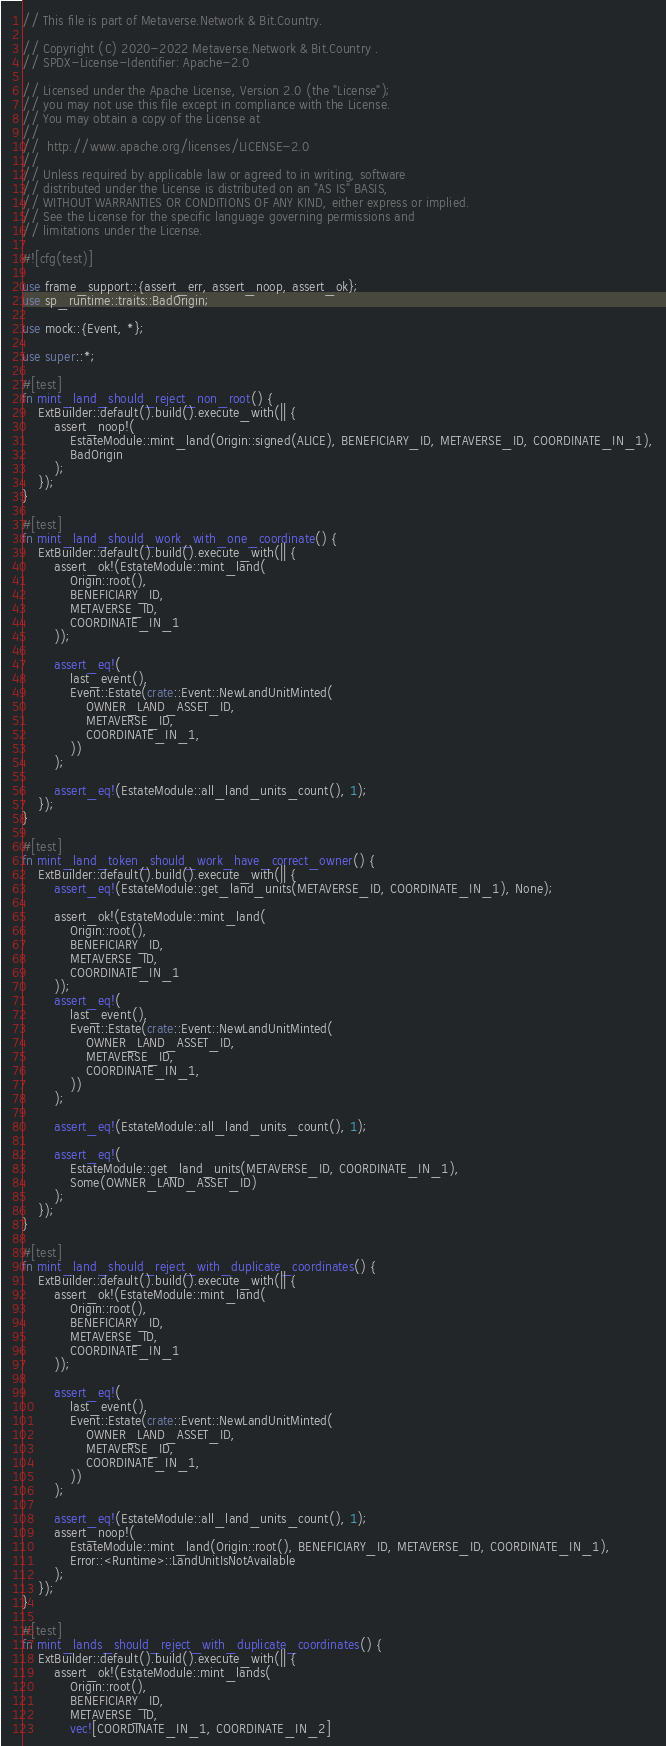Convert code to text. <code><loc_0><loc_0><loc_500><loc_500><_Rust_>// This file is part of Metaverse.Network & Bit.Country.

// Copyright (C) 2020-2022 Metaverse.Network & Bit.Country .
// SPDX-License-Identifier: Apache-2.0

// Licensed under the Apache License, Version 2.0 (the "License");
// you may not use this file except in compliance with the License.
// You may obtain a copy of the License at
//
// 	http://www.apache.org/licenses/LICENSE-2.0
//
// Unless required by applicable law or agreed to in writing, software
// distributed under the License is distributed on an "AS IS" BASIS,
// WITHOUT WARRANTIES OR CONDITIONS OF ANY KIND, either express or implied.
// See the License for the specific language governing permissions and
// limitations under the License.

#![cfg(test)]

use frame_support::{assert_err, assert_noop, assert_ok};
use sp_runtime::traits::BadOrigin;

use mock::{Event, *};

use super::*;

#[test]
fn mint_land_should_reject_non_root() {
	ExtBuilder::default().build().execute_with(|| {
		assert_noop!(
			EstateModule::mint_land(Origin::signed(ALICE), BENEFICIARY_ID, METAVERSE_ID, COORDINATE_IN_1),
			BadOrigin
		);
	});
}

#[test]
fn mint_land_should_work_with_one_coordinate() {
	ExtBuilder::default().build().execute_with(|| {
		assert_ok!(EstateModule::mint_land(
			Origin::root(),
			BENEFICIARY_ID,
			METAVERSE_ID,
			COORDINATE_IN_1
		));

		assert_eq!(
			last_event(),
			Event::Estate(crate::Event::NewLandUnitMinted(
				OWNER_LAND_ASSET_ID,
				METAVERSE_ID,
				COORDINATE_IN_1,
			))
		);

		assert_eq!(EstateModule::all_land_units_count(), 1);
	});
}

#[test]
fn mint_land_token_should_work_have_correct_owner() {
	ExtBuilder::default().build().execute_with(|| {
		assert_eq!(EstateModule::get_land_units(METAVERSE_ID, COORDINATE_IN_1), None);

		assert_ok!(EstateModule::mint_land(
			Origin::root(),
			BENEFICIARY_ID,
			METAVERSE_ID,
			COORDINATE_IN_1
		));
		assert_eq!(
			last_event(),
			Event::Estate(crate::Event::NewLandUnitMinted(
				OWNER_LAND_ASSET_ID,
				METAVERSE_ID,
				COORDINATE_IN_1,
			))
		);

		assert_eq!(EstateModule::all_land_units_count(), 1);

		assert_eq!(
			EstateModule::get_land_units(METAVERSE_ID, COORDINATE_IN_1),
			Some(OWNER_LAND_ASSET_ID)
		);
	});
}

#[test]
fn mint_land_should_reject_with_duplicate_coordinates() {
	ExtBuilder::default().build().execute_with(|| {
		assert_ok!(EstateModule::mint_land(
			Origin::root(),
			BENEFICIARY_ID,
			METAVERSE_ID,
			COORDINATE_IN_1
		));

		assert_eq!(
			last_event(),
			Event::Estate(crate::Event::NewLandUnitMinted(
				OWNER_LAND_ASSET_ID,
				METAVERSE_ID,
				COORDINATE_IN_1,
			))
		);

		assert_eq!(EstateModule::all_land_units_count(), 1);
		assert_noop!(
			EstateModule::mint_land(Origin::root(), BENEFICIARY_ID, METAVERSE_ID, COORDINATE_IN_1),
			Error::<Runtime>::LandUnitIsNotAvailable
		);
	});
}

#[test]
fn mint_lands_should_reject_with_duplicate_coordinates() {
	ExtBuilder::default().build().execute_with(|| {
		assert_ok!(EstateModule::mint_lands(
			Origin::root(),
			BENEFICIARY_ID,
			METAVERSE_ID,
			vec![COORDINATE_IN_1, COORDINATE_IN_2]</code> 